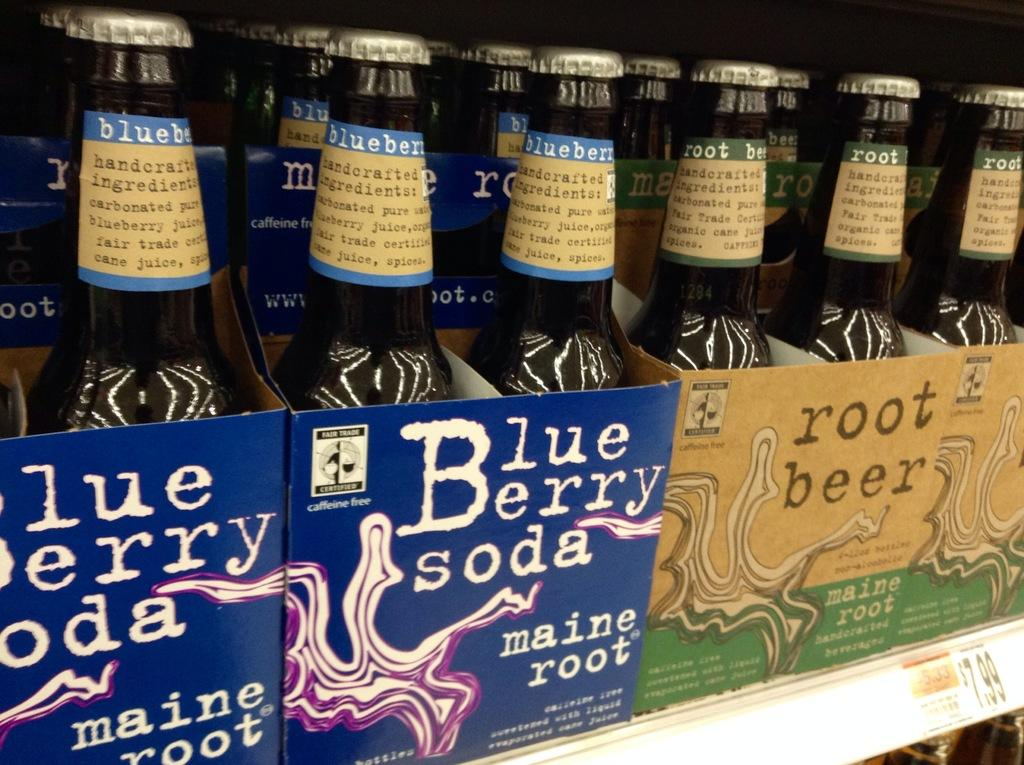<image>
Present a compact description of the photo's key features. Sixpacks of soda are on a shelf, including blueberry soda and root beer. 